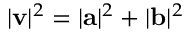Convert formula to latex. <formula><loc_0><loc_0><loc_500><loc_500>| v | ^ { 2 } = | a | ^ { 2 } + | b | ^ { 2 }</formula> 